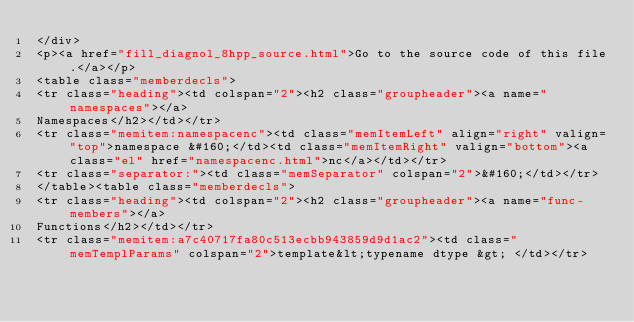Convert code to text. <code><loc_0><loc_0><loc_500><loc_500><_HTML_></div>
<p><a href="fill_diagnol_8hpp_source.html">Go to the source code of this file.</a></p>
<table class="memberdecls">
<tr class="heading"><td colspan="2"><h2 class="groupheader"><a name="namespaces"></a>
Namespaces</h2></td></tr>
<tr class="memitem:namespacenc"><td class="memItemLeft" align="right" valign="top">namespace &#160;</td><td class="memItemRight" valign="bottom"><a class="el" href="namespacenc.html">nc</a></td></tr>
<tr class="separator:"><td class="memSeparator" colspan="2">&#160;</td></tr>
</table><table class="memberdecls">
<tr class="heading"><td colspan="2"><h2 class="groupheader"><a name="func-members"></a>
Functions</h2></td></tr>
<tr class="memitem:a7c40717fa80c513ecbb943859d9d1ac2"><td class="memTemplParams" colspan="2">template&lt;typename dtype &gt; </td></tr></code> 